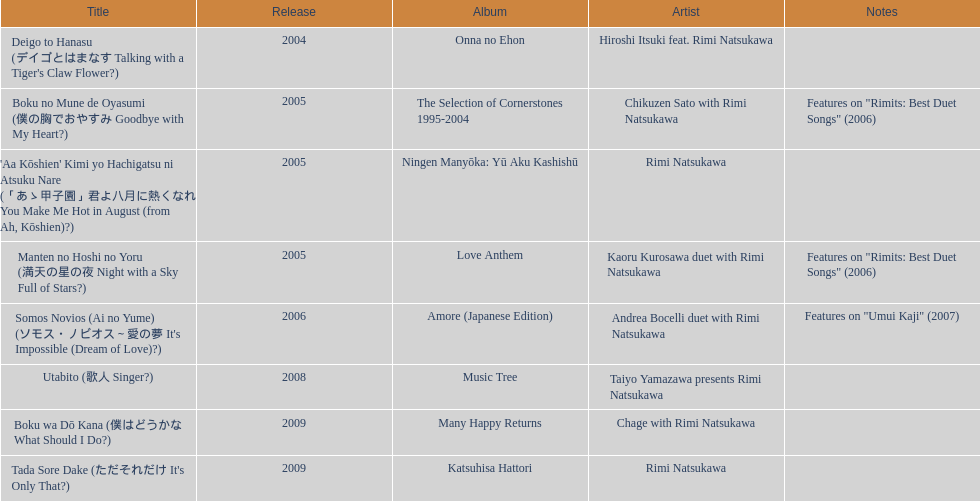What year was the first title released? 2004. 